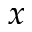Convert formula to latex. <formula><loc_0><loc_0><loc_500><loc_500>x</formula> 